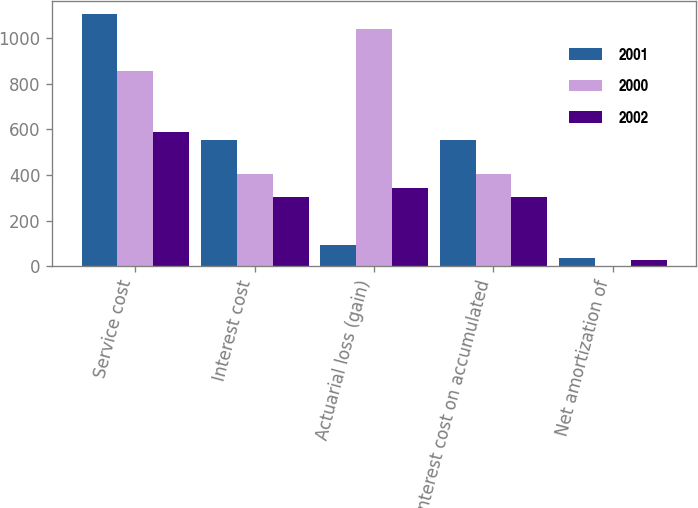<chart> <loc_0><loc_0><loc_500><loc_500><stacked_bar_chart><ecel><fcel>Service cost<fcel>Interest cost<fcel>Actuarial loss (gain)<fcel>Interest cost on accumulated<fcel>Net amortization of<nl><fcel>2001<fcel>1107<fcel>553<fcel>95<fcel>553<fcel>35<nl><fcel>2000<fcel>855<fcel>406<fcel>1038<fcel>406<fcel>3<nl><fcel>2002<fcel>587<fcel>304<fcel>341<fcel>304<fcel>29<nl></chart> 